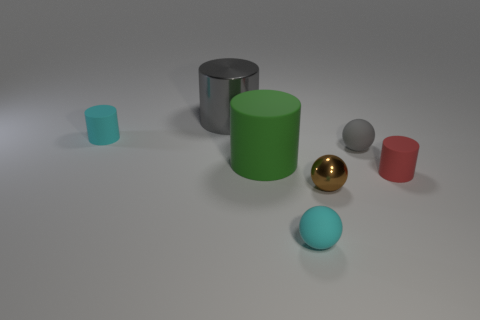Subtract 1 cylinders. How many cylinders are left? 3 Subtract all green cylinders. Subtract all yellow cubes. How many cylinders are left? 3 Add 2 large green spheres. How many objects exist? 9 Subtract all cylinders. How many objects are left? 3 Subtract 0 purple blocks. How many objects are left? 7 Subtract all brown rubber objects. Subtract all small cyan matte cylinders. How many objects are left? 6 Add 6 large gray objects. How many large gray objects are left? 7 Add 1 gray things. How many gray things exist? 3 